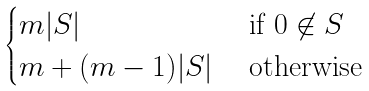<formula> <loc_0><loc_0><loc_500><loc_500>\begin{cases} m | S | & \text { if $0 \not\in S$ } \\ m + ( m - 1 ) | S | & \text { otherwise } \end{cases}</formula> 